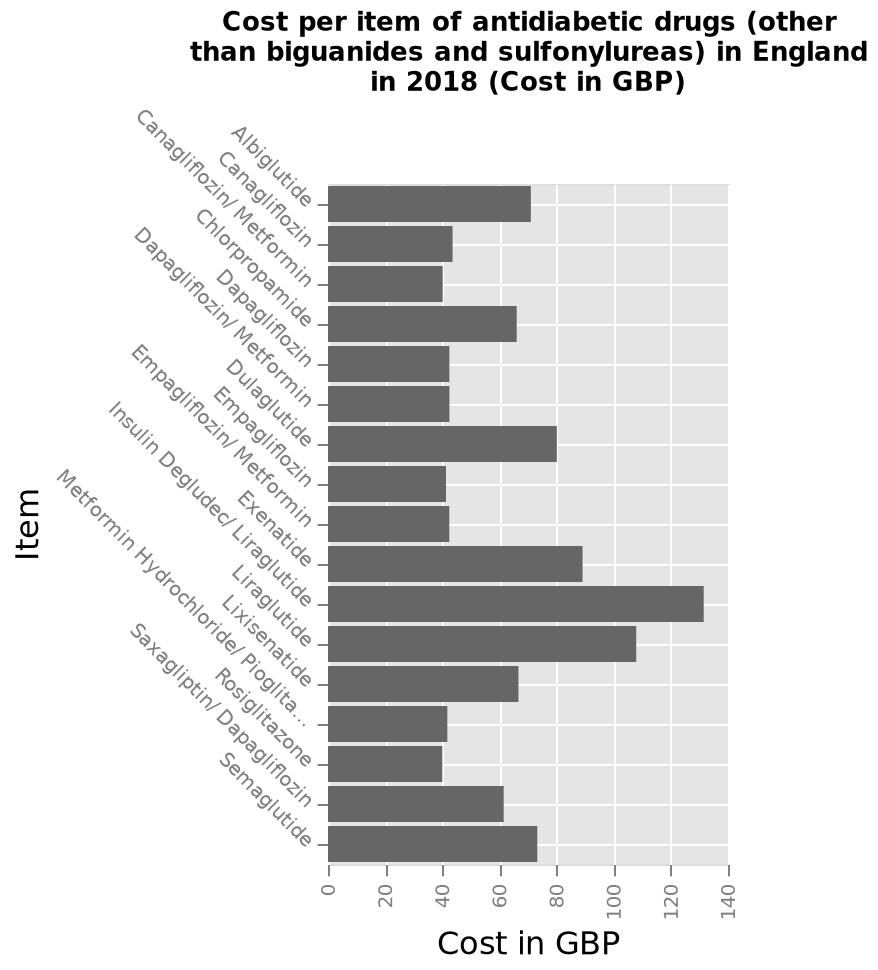<image>
Which antidiabetic drug is at one end of the y-axis? Albiglutide is at one end of the y-axis. What is the unit of measurement for the cost per item in the bar plot?  The unit of measurement for the cost per item in the bar plot is GBP (British Pound). 